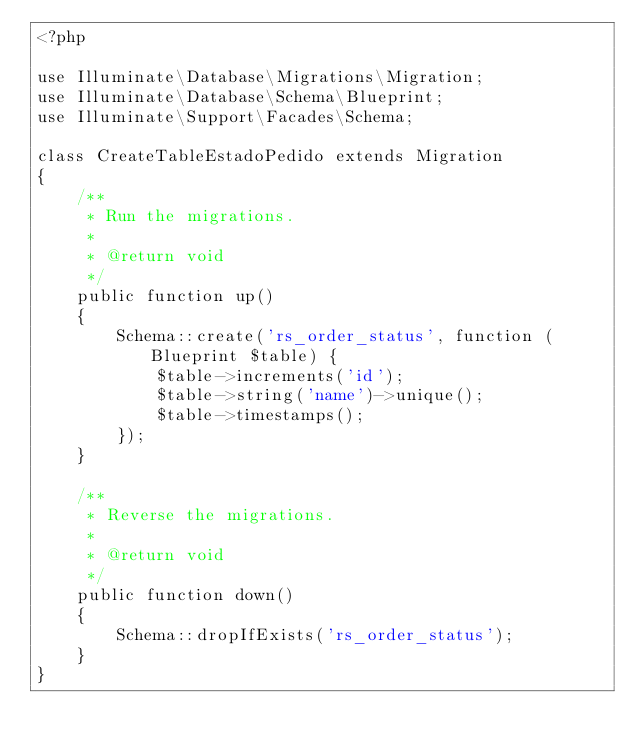Convert code to text. <code><loc_0><loc_0><loc_500><loc_500><_PHP_><?php

use Illuminate\Database\Migrations\Migration;
use Illuminate\Database\Schema\Blueprint;
use Illuminate\Support\Facades\Schema;

class CreateTableEstadoPedido extends Migration
{
    /**
     * Run the migrations.
     *
     * @return void
     */
    public function up()
    {
        Schema::create('rs_order_status', function (Blueprint $table) {
            $table->increments('id');
            $table->string('name')->unique();
            $table->timestamps();
        });
    }

    /**
     * Reverse the migrations.
     *
     * @return void
     */
    public function down()
    {
        Schema::dropIfExists('rs_order_status');
    }
}
</code> 